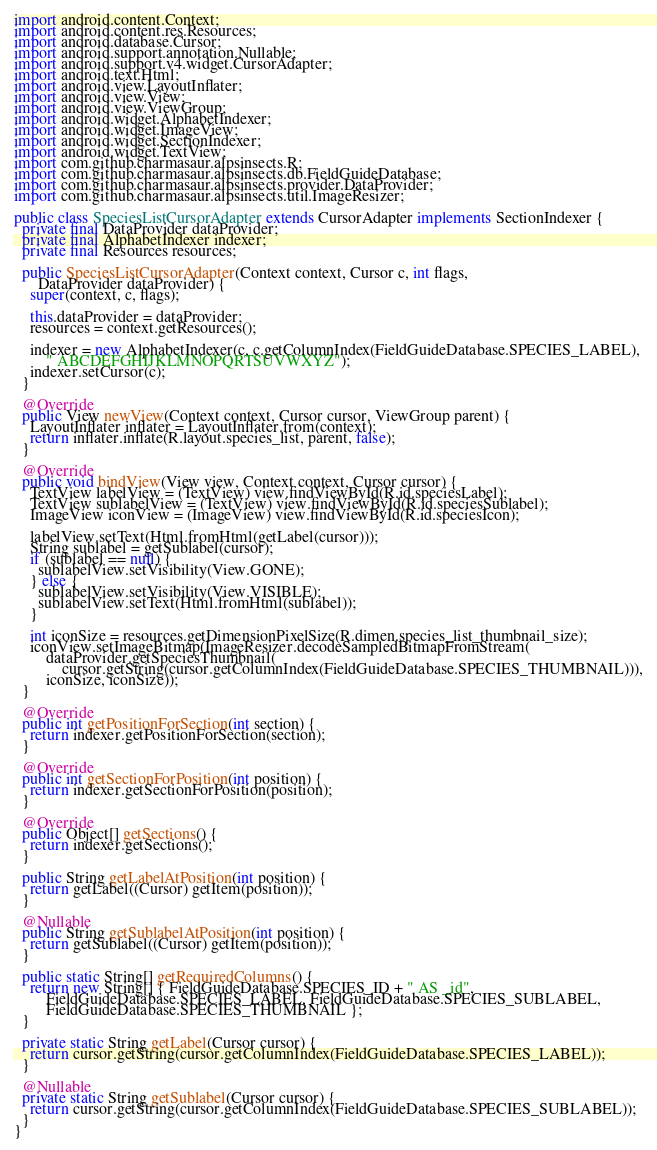Convert code to text. <code><loc_0><loc_0><loc_500><loc_500><_Java_>
import android.content.Context;
import android.content.res.Resources;
import android.database.Cursor;
import android.support.annotation.Nullable;
import android.support.v4.widget.CursorAdapter;
import android.text.Html;
import android.view.LayoutInflater;
import android.view.View;
import android.view.ViewGroup;
import android.widget.AlphabetIndexer;
import android.widget.ImageView;
import android.widget.SectionIndexer;
import android.widget.TextView;
import com.github.charmasaur.alpsinsects.R;
import com.github.charmasaur.alpsinsects.db.FieldGuideDatabase;
import com.github.charmasaur.alpsinsects.provider.DataProvider;
import com.github.charmasaur.alpsinsects.util.ImageResizer;

public class SpeciesListCursorAdapter extends CursorAdapter implements SectionIndexer {
  private final DataProvider dataProvider;
  private final AlphabetIndexer indexer;
  private final Resources resources;

  public SpeciesListCursorAdapter(Context context, Cursor c, int flags,
      DataProvider dataProvider) {
    super(context, c, flags);

    this.dataProvider = dataProvider;
    resources = context.getResources();

    indexer = new AlphabetIndexer(c, c.getColumnIndex(FieldGuideDatabase.SPECIES_LABEL),
        " ABCDEFGHIJKLMNOPQRTSUVWXYZ");
    indexer.setCursor(c);
  }

  @Override
  public View newView(Context context, Cursor cursor, ViewGroup parent) {
    LayoutInflater inflater = LayoutInflater.from(context);
    return inflater.inflate(R.layout.species_list, parent, false);
  }

  @Override
  public void bindView(View view, Context context, Cursor cursor) {
    TextView labelView = (TextView) view.findViewById(R.id.speciesLabel);
    TextView sublabelView = (TextView) view.findViewById(R.id.speciesSublabel);
    ImageView iconView = (ImageView) view.findViewById(R.id.speciesIcon);

    labelView.setText(Html.fromHtml(getLabel(cursor)));
    String sublabel = getSublabel(cursor);
    if (sublabel == null) {
      sublabelView.setVisibility(View.GONE);
    } else {
      sublabelView.setVisibility(View.VISIBLE);
      sublabelView.setText(Html.fromHtml(sublabel));
    }

    int iconSize = resources.getDimensionPixelSize(R.dimen.species_list_thumbnail_size);
    iconView.setImageBitmap(ImageResizer.decodeSampledBitmapFromStream(
        dataProvider.getSpeciesThumbnail(
            cursor.getString(cursor.getColumnIndex(FieldGuideDatabase.SPECIES_THUMBNAIL))),
        iconSize, iconSize));
  }

  @Override
  public int getPositionForSection(int section) {
    return indexer.getPositionForSection(section);
  }

  @Override
  public int getSectionForPosition(int position) {
    return indexer.getSectionForPosition(position);
  }

  @Override
  public Object[] getSections() {
    return indexer.getSections();
  }

  public String getLabelAtPosition(int position) {
    return getLabel((Cursor) getItem(position));
  }

  @Nullable
  public String getSublabelAtPosition(int position) {
    return getSublabel((Cursor) getItem(position));
  }

  public static String[] getRequiredColumns() {
    return new String[] { FieldGuideDatabase.SPECIES_ID + " AS _id",
        FieldGuideDatabase.SPECIES_LABEL, FieldGuideDatabase.SPECIES_SUBLABEL,
        FieldGuideDatabase.SPECIES_THUMBNAIL };
  }

  private static String getLabel(Cursor cursor) {
    return cursor.getString(cursor.getColumnIndex(FieldGuideDatabase.SPECIES_LABEL));
  }

  @Nullable
  private static String getSublabel(Cursor cursor) {
    return cursor.getString(cursor.getColumnIndex(FieldGuideDatabase.SPECIES_SUBLABEL));
  }
}
</code> 